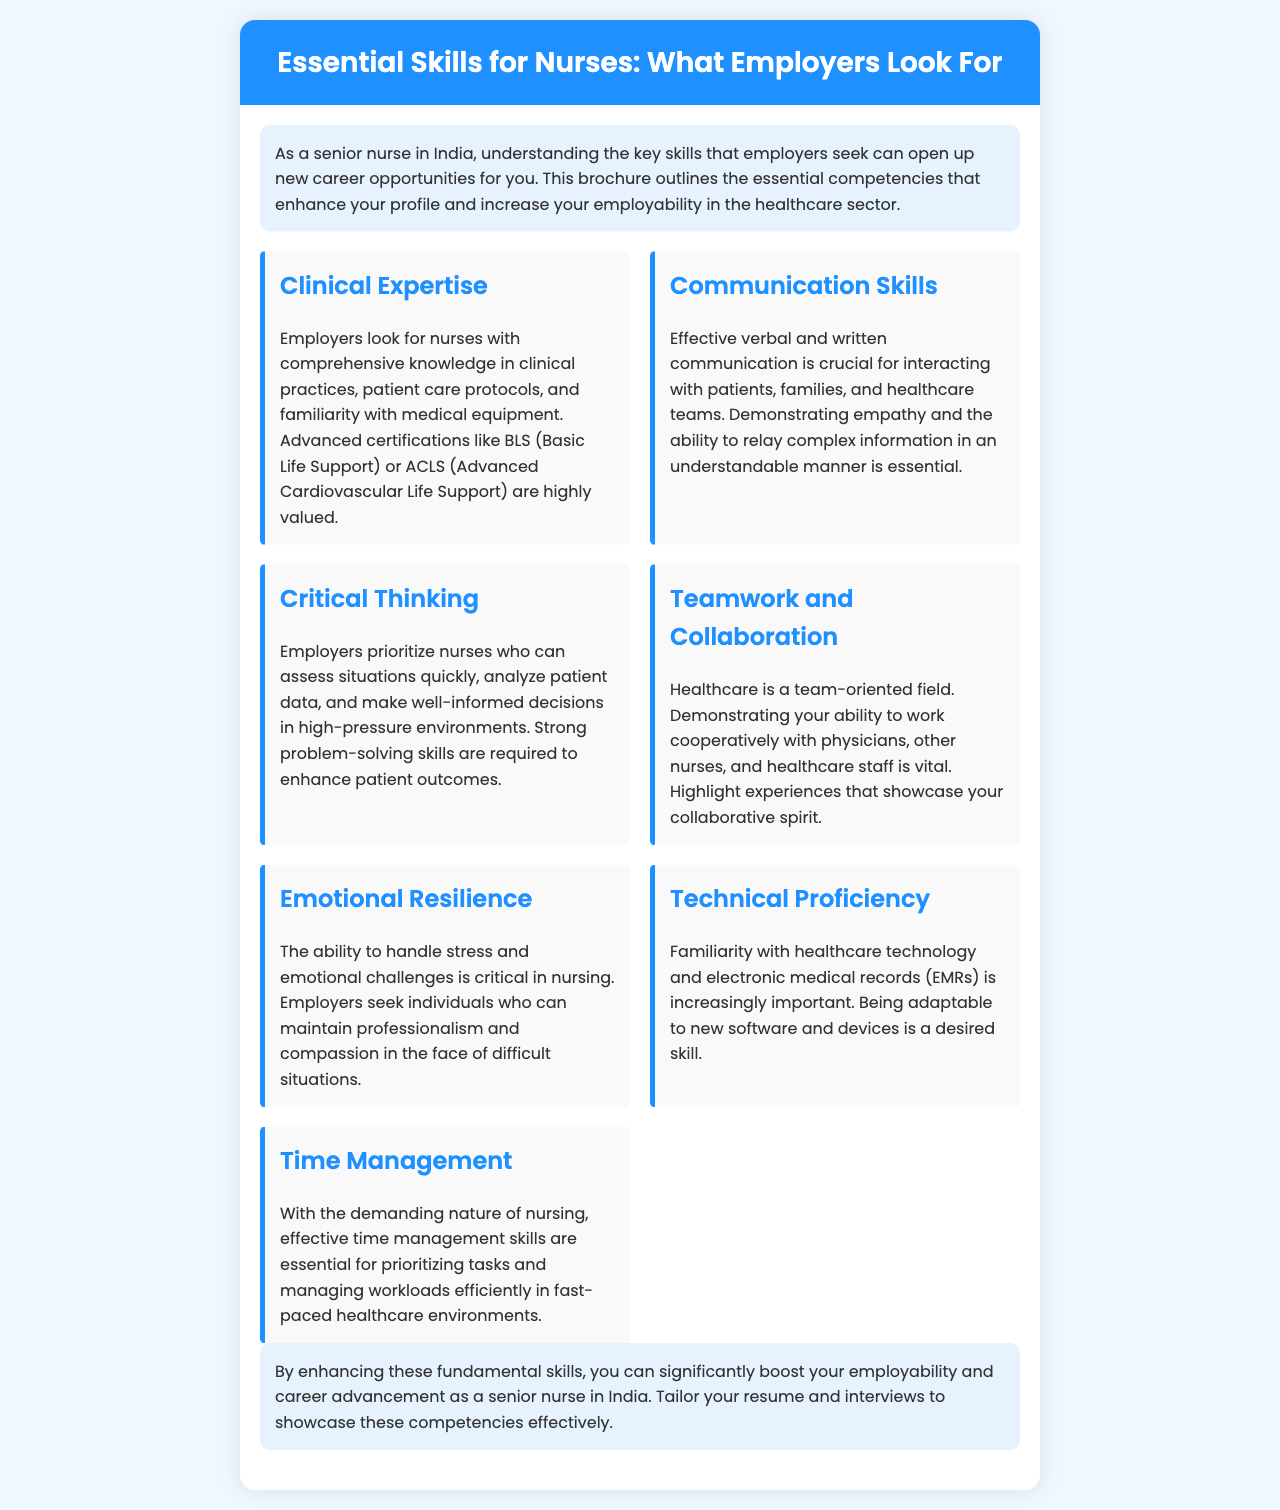What is the title of the brochure? The title of the brochure is written prominently at the top of the document.
Answer: Essential Skills for Nurses: What Employers Look For How many essential skills are listed in the brochure? The brochure includes a specific number of skills presented in individual skill cards.
Answer: Seven What skill emphasizes the ability to handle stress? The brochure describes a specific skill that relates to managing emotional challenges during nursing.
Answer: Emotional Resilience Which advanced certifications are mentioned as valuable? The brochure lists specific certifications related to clinical expertise that are sought after by employers.
Answer: BLS (Basic Life Support) or ACLS (Advanced Cardiovascular Life Support) What is essential for effective interaction with patients and families? The brochure indicates a specific skill that focuses on the importance of communication in nursing roles.
Answer: Communication Skills What skill is vital for managing workloads efficiently in healthcare? The brochure points out a skill that helps nurses prioritize tasks and responsibilities in their daily routines.
Answer: Time Management What does the brochure suggest you tailor to showcase your competencies? The conclusion section of the brochure recommends adjusting something to highlight essential skills effectively during the job application process.
Answer: Resume and interviews 